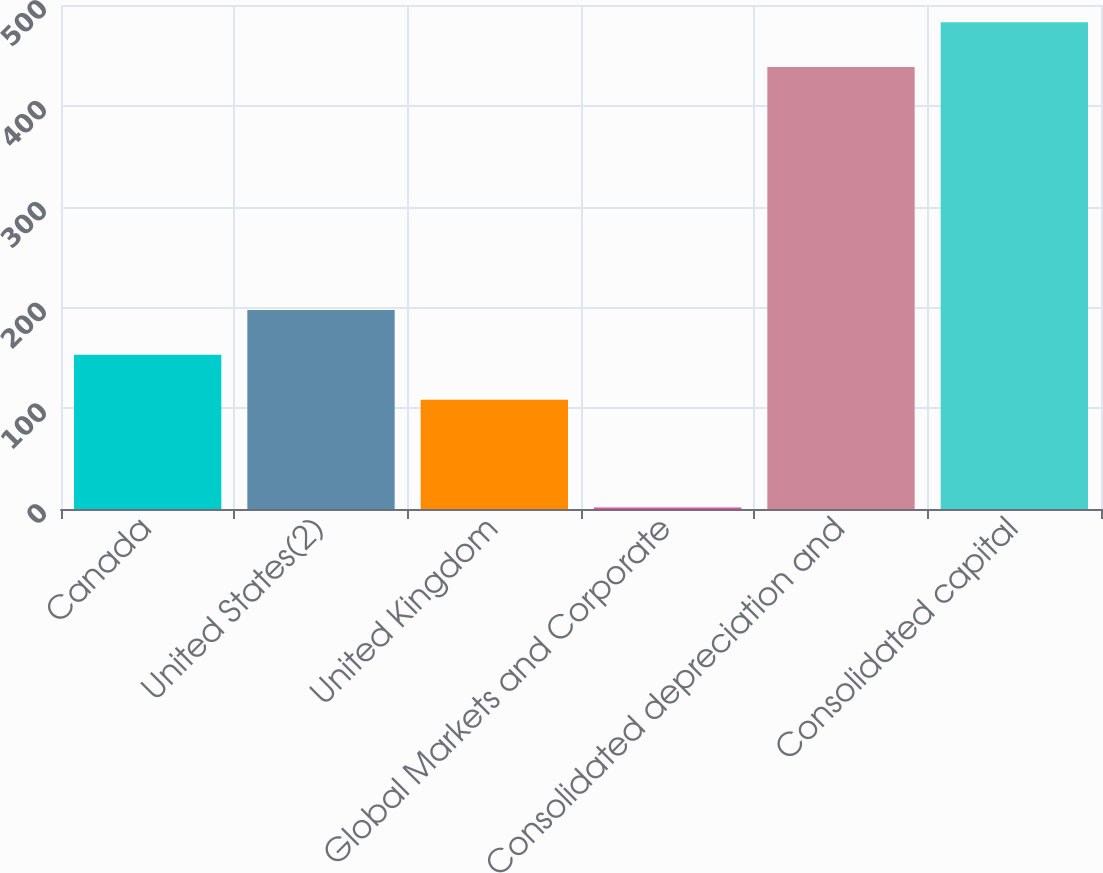Convert chart to OTSL. <chart><loc_0><loc_0><loc_500><loc_500><bar_chart><fcel>Canada<fcel>United States(2)<fcel>United Kingdom<fcel>Global Markets and Corporate<fcel>Consolidated depreciation and<fcel>Consolidated capital<nl><fcel>152.98<fcel>197.46<fcel>108.5<fcel>1.6<fcel>438.4<fcel>482.88<nl></chart> 